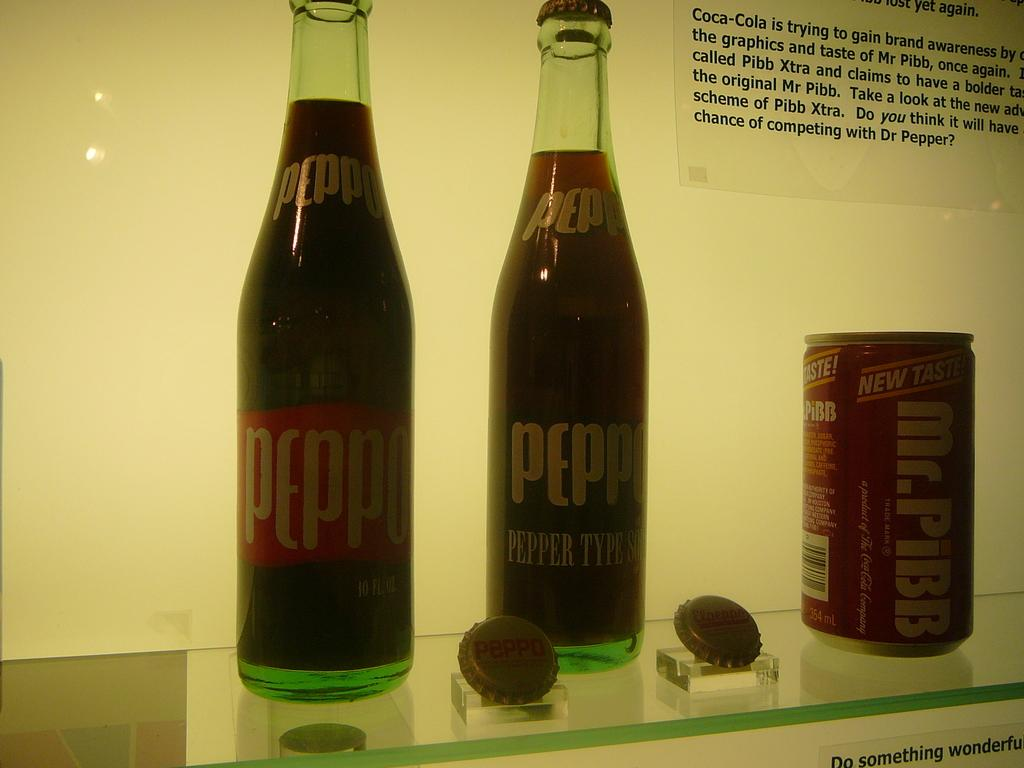<image>
Give a short and clear explanation of the subsequent image. 2 bottles of peppo, can of mr pibb, and a card describing how coca-cola created mr pibb 